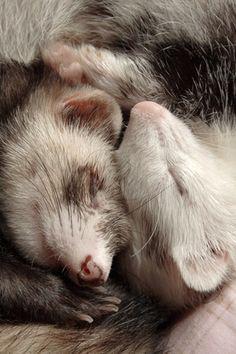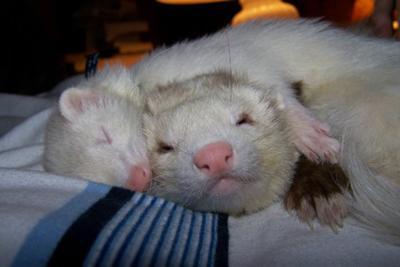The first image is the image on the left, the second image is the image on the right. Considering the images on both sides, is "In the left image, there are two ferrets." valid? Answer yes or no. Yes. The first image is the image on the left, the second image is the image on the right. Analyze the images presented: Is the assertion "There are ferrets cuddling with other species of animals." valid? Answer yes or no. No. 